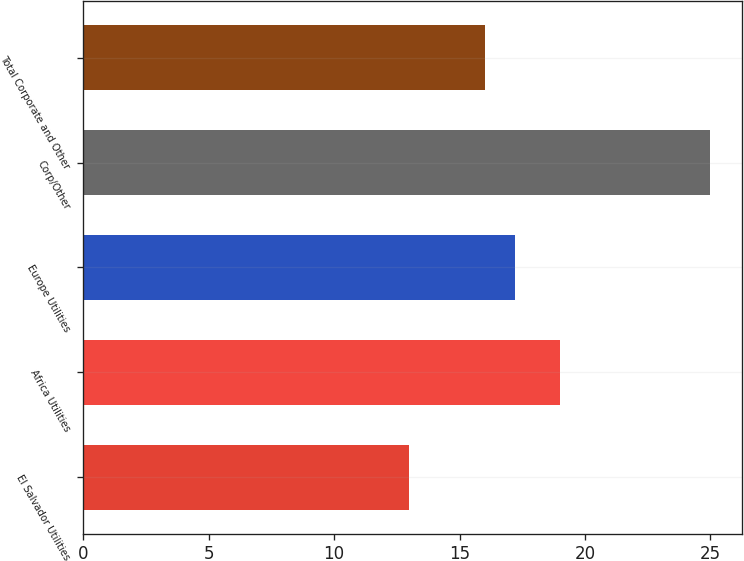Convert chart to OTSL. <chart><loc_0><loc_0><loc_500><loc_500><bar_chart><fcel>El Salvador Utilities<fcel>Africa Utilities<fcel>Europe Utilities<fcel>Corp/Other<fcel>Total Corporate and Other<nl><fcel>13<fcel>19<fcel>17.2<fcel>25<fcel>16<nl></chart> 